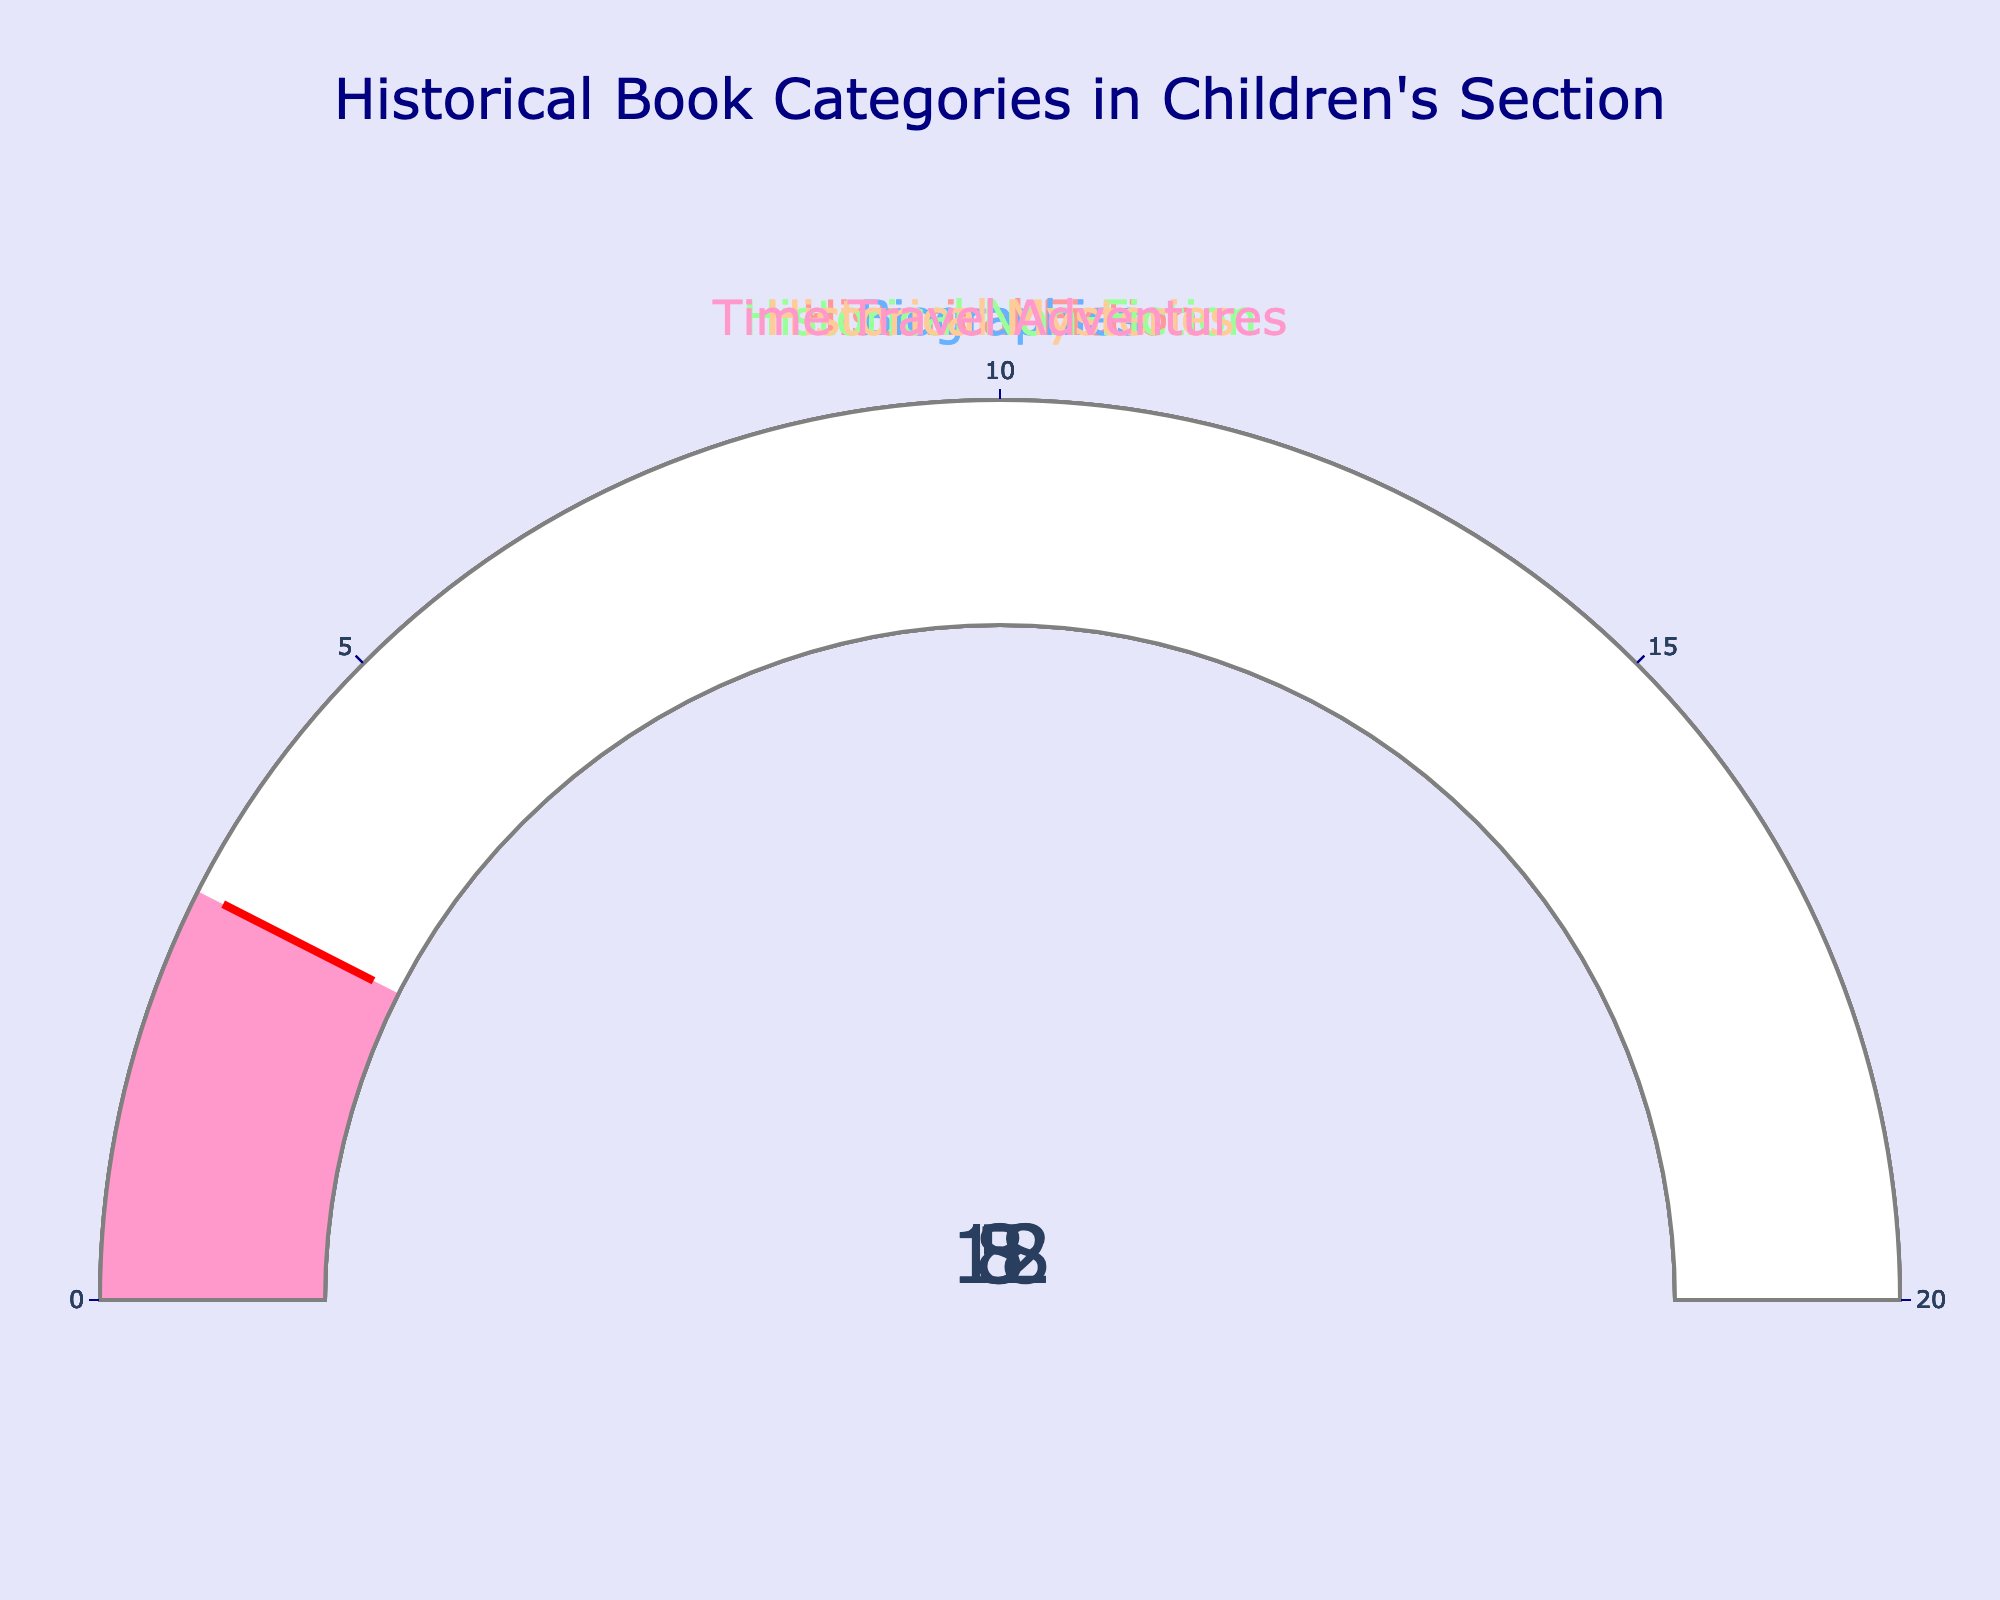What's the title of the figure? The title of the figure is displayed at the top of the plot in large, navy-colored font.
Answer: Historical Book Categories in Children's Section How much percentage does Historical Fiction cover in the library's children's section? The gauge for Historical Fiction shows a percentage, which is the numerical value at the center.
Answer: 18% Which genre has the smallest percentage among the historical book categories? Comparing the gauges, Time Travel Adventures has the smallest value displayed.
Answer: 3% What is the combined percentage of Biographies and Historical Non-Fiction? Add the percentages shown on the gauges for Biographies and Historical Non-Fiction: 12 + 8.
Answer: 20% Which genre has a higher percentage, Historical Mysteries or Time Travel Adventures? Compare the values displayed on the gauges for both genres; Historical Mysteries shows a higher percentage than Time Travel Adventures.
Answer: Historical Mysteries What is the average percentage of all the genres combined? Sum the percentages of all categories (18 + 12 + 8 + 5 + 3) and then divide by the number of categories (5): (18 + 12 + 8 + 5 + 3) / 5.
Answer: 9.2% Is the percentage of Historical Fiction closer to the upper or lower limit of the gauge's range? The maximum value of the gauge range is 20, and the value displayed on Historical Fiction gauge is 18, which is closer to 20.
Answer: Upper limit By how much does the percentage of Historical Fiction exceed that of Historical Non-Fiction? Subtract the percentage of Historical Non-Fiction from the percentage of Historical Fiction: 18 - 8.
Answer: 10% If the library adds enough Historical Mysteries books to make its percentage equal to Historical Non-Fiction, how much percentage would need to be added? Increase the percentage of Historical Mysteries from 5 to 8, thus adding 8 - 5.
Answer: 3% What color is used for the gauge representing Biographies? The gauge representing Biographies uses the second color in the sequence, which is visually represented as a shade of blue.
Answer: Blue 